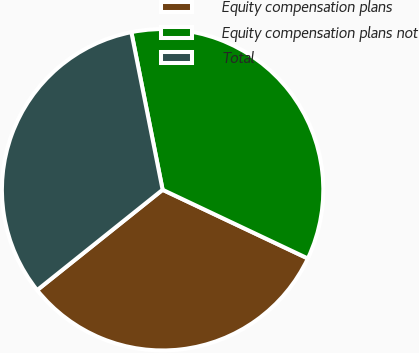Convert chart. <chart><loc_0><loc_0><loc_500><loc_500><pie_chart><fcel>Equity compensation plans<fcel>Equity compensation plans not<fcel>Total<nl><fcel>32.23%<fcel>35.15%<fcel>32.62%<nl></chart> 